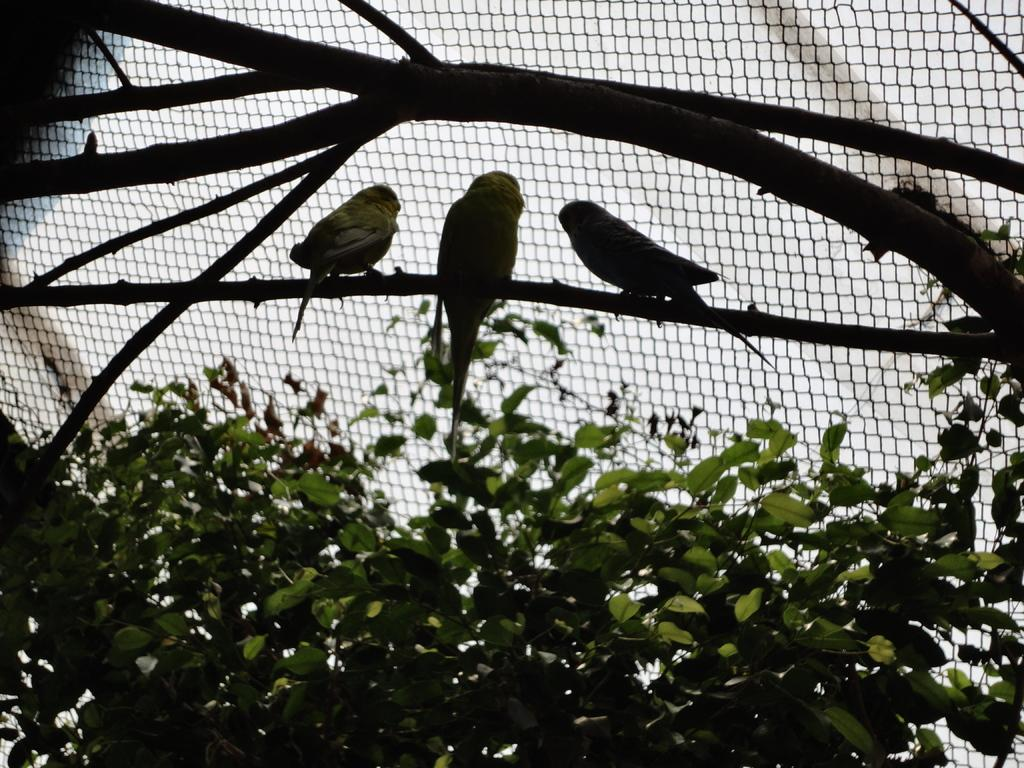What type of animals can be seen in the image? There are birds in the image. Where are the birds located? The birds are on a branch in the image. What type of vegetation is present in the image? There are green leaves in the image. What can be seen in the background of the image? There is a net visible in the image. What is the governor doing in the image? There is no governor present in the image; it features birds on a branch with green leaves and a net. How does the servant help the birds in the image? There is no servant present in the image, and the birds do not require assistance. 